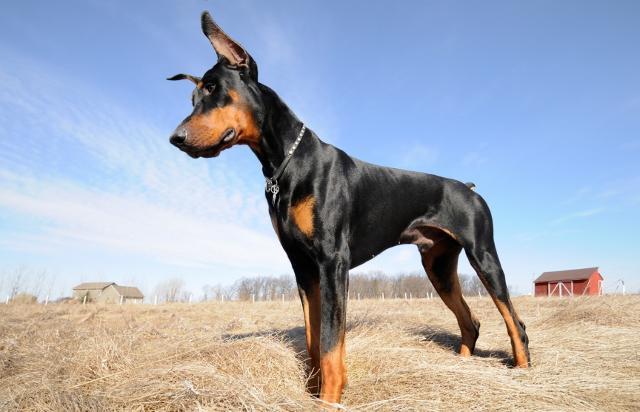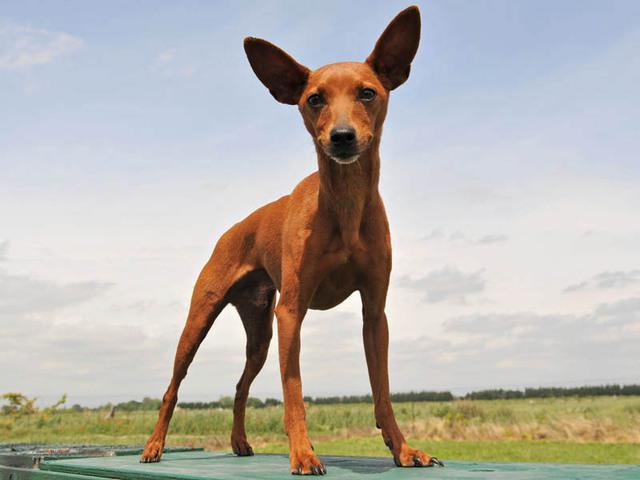The first image is the image on the left, the second image is the image on the right. Assess this claim about the two images: "Only one dog has a collar on". Correct or not? Answer yes or no. Yes. The first image is the image on the left, the second image is the image on the right. Assess this claim about the two images: "All dogs gaze leftward and are dobermans with erect ears, and one dog has its mouth open and tongue hanging past its lower lip.". Correct or not? Answer yes or no. No. 